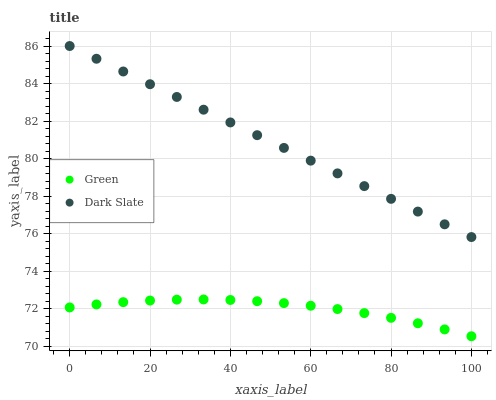Does Green have the minimum area under the curve?
Answer yes or no. Yes. Does Dark Slate have the maximum area under the curve?
Answer yes or no. Yes. Does Green have the maximum area under the curve?
Answer yes or no. No. Is Dark Slate the smoothest?
Answer yes or no. Yes. Is Green the roughest?
Answer yes or no. Yes. Is Green the smoothest?
Answer yes or no. No. Does Green have the lowest value?
Answer yes or no. Yes. Does Dark Slate have the highest value?
Answer yes or no. Yes. Does Green have the highest value?
Answer yes or no. No. Is Green less than Dark Slate?
Answer yes or no. Yes. Is Dark Slate greater than Green?
Answer yes or no. Yes. Does Green intersect Dark Slate?
Answer yes or no. No. 